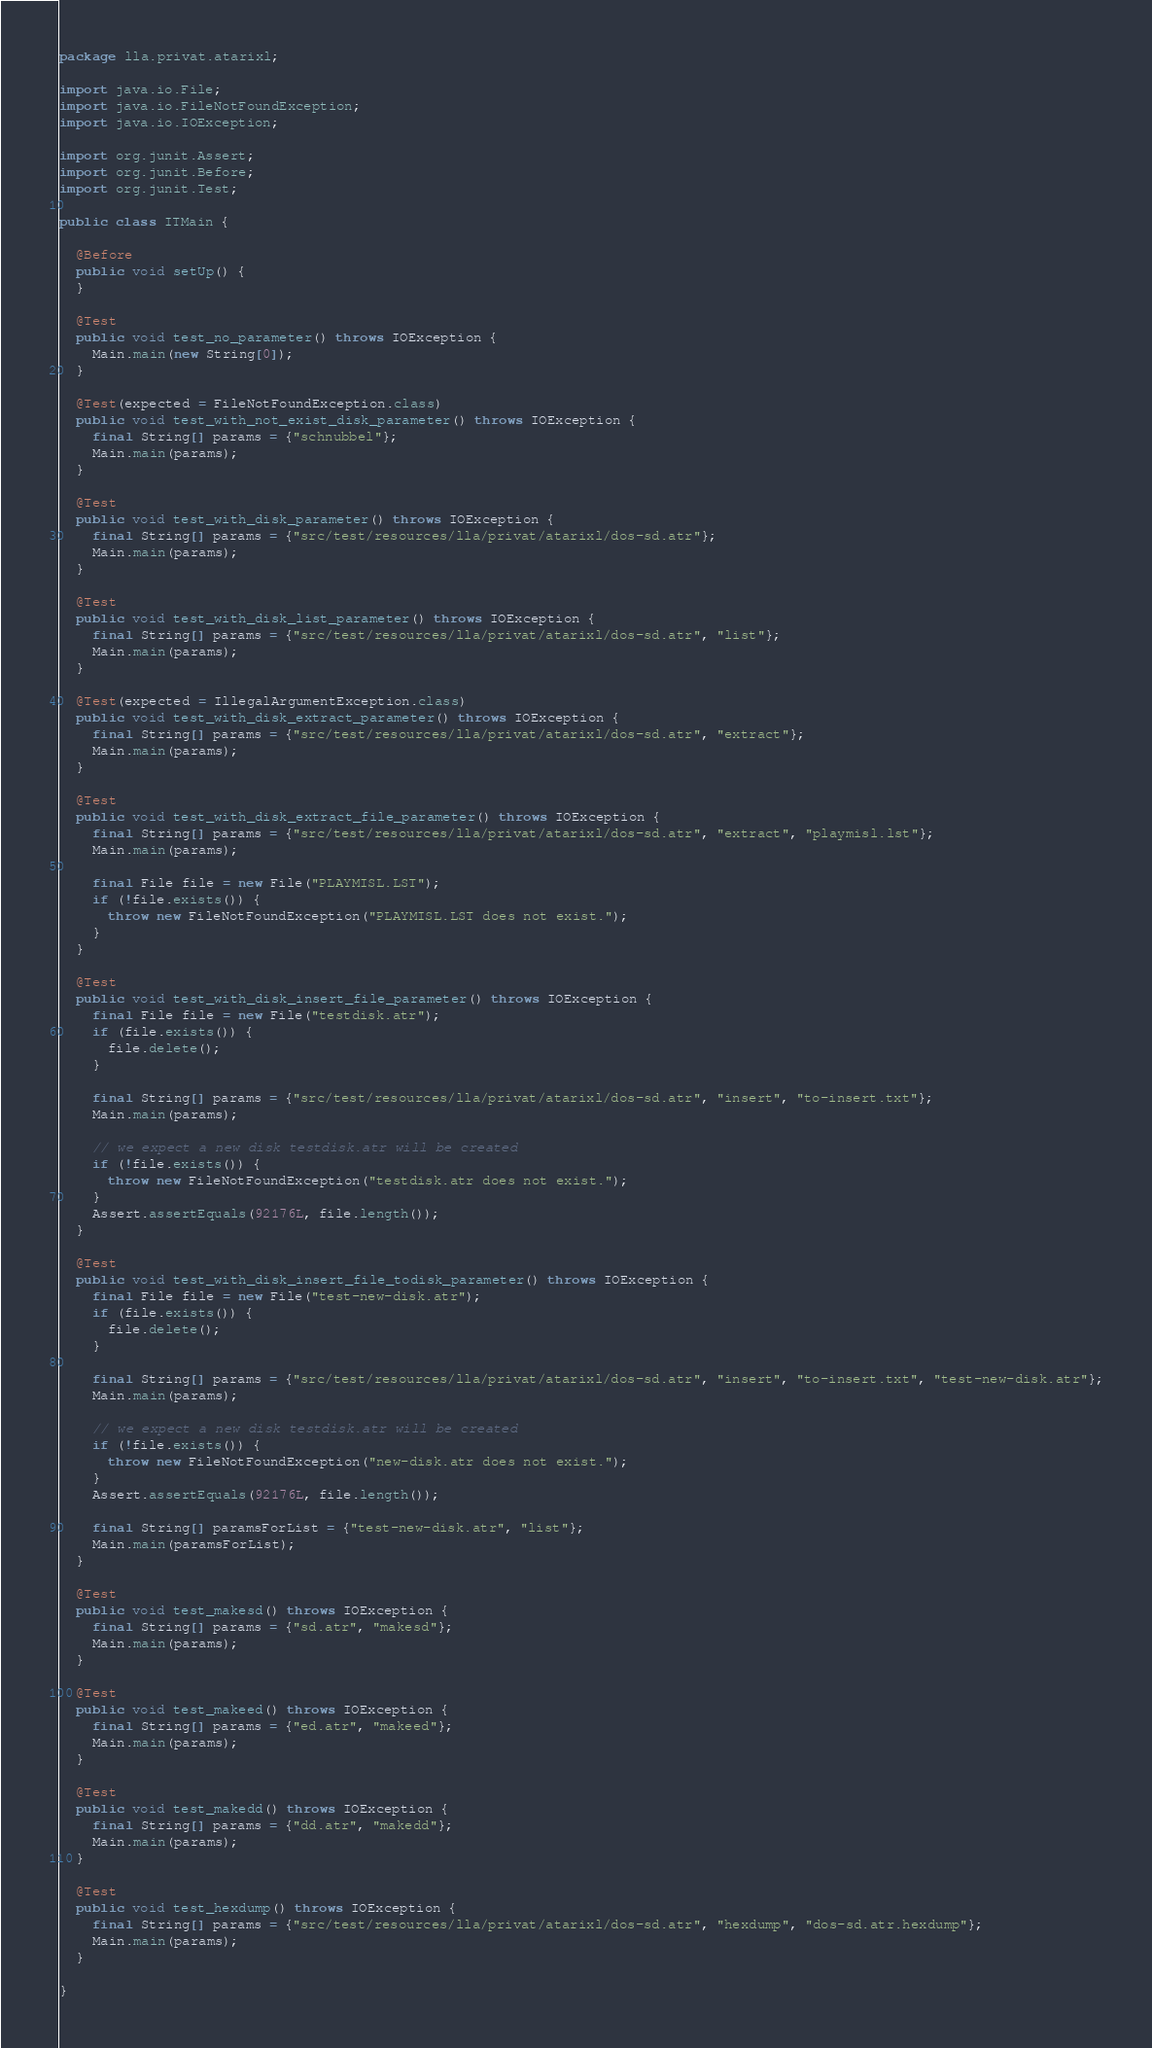Convert code to text. <code><loc_0><loc_0><loc_500><loc_500><_Java_>package lla.privat.atarixl;

import java.io.File;
import java.io.FileNotFoundException;
import java.io.IOException;

import org.junit.Assert;
import org.junit.Before;
import org.junit.Test;

public class ITMain {

  @Before
  public void setUp() {
  }

  @Test
  public void test_no_parameter() throws IOException {
    Main.main(new String[0]);
  }

  @Test(expected = FileNotFoundException.class)
  public void test_with_not_exist_disk_parameter() throws IOException {
    final String[] params = {"schnubbel"};
    Main.main(params);
  }

  @Test
  public void test_with_disk_parameter() throws IOException {
    final String[] params = {"src/test/resources/lla/privat/atarixl/dos-sd.atr"};
    Main.main(params);
  }

  @Test
  public void test_with_disk_list_parameter() throws IOException {
    final String[] params = {"src/test/resources/lla/privat/atarixl/dos-sd.atr", "list"};
    Main.main(params);
  }

  @Test(expected = IllegalArgumentException.class)
  public void test_with_disk_extract_parameter() throws IOException {
    final String[] params = {"src/test/resources/lla/privat/atarixl/dos-sd.atr", "extract"};
    Main.main(params);
  }
  
  @Test
  public void test_with_disk_extract_file_parameter() throws IOException {
    final String[] params = {"src/test/resources/lla/privat/atarixl/dos-sd.atr", "extract", "playmisl.lst"};
    Main.main(params);

    final File file = new File("PLAYMISL.LST");
    if (!file.exists()) {
      throw new FileNotFoundException("PLAYMISL.LST does not exist.");
    }
  }

  @Test
  public void test_with_disk_insert_file_parameter() throws IOException {
    final File file = new File("testdisk.atr");
    if (file.exists()) {
      file.delete();
    }

    final String[] params = {"src/test/resources/lla/privat/atarixl/dos-sd.atr", "insert", "to-insert.txt"};
    Main.main(params);

    // we expect a new disk testdisk.atr will be created
    if (!file.exists()) {
      throw new FileNotFoundException("testdisk.atr does not exist.");
    }
    Assert.assertEquals(92176L, file.length());
  }

  @Test
  public void test_with_disk_insert_file_todisk_parameter() throws IOException {
    final File file = new File("test-new-disk.atr");
    if (file.exists()) {
      file.delete();
    }

    final String[] params = {"src/test/resources/lla/privat/atarixl/dos-sd.atr", "insert", "to-insert.txt", "test-new-disk.atr"};
    Main.main(params);

    // we expect a new disk testdisk.atr will be created
    if (!file.exists()) {
      throw new FileNotFoundException("new-disk.atr does not exist.");
    }
    Assert.assertEquals(92176L, file.length());

    final String[] paramsForList = {"test-new-disk.atr", "list"};
    Main.main(paramsForList);
  }

  @Test
  public void test_makesd() throws IOException {
    final String[] params = {"sd.atr", "makesd"};
    Main.main(params);
  }

  @Test
  public void test_makeed() throws IOException {
    final String[] params = {"ed.atr", "makeed"};
    Main.main(params);
  }

  @Test
  public void test_makedd() throws IOException {
    final String[] params = {"dd.atr", "makedd"};
    Main.main(params);
  }

  @Test
  public void test_hexdump() throws IOException {
    final String[] params = {"src/test/resources/lla/privat/atarixl/dos-sd.atr", "hexdump", "dos-sd.atr.hexdump"};
    Main.main(params);
  }

}
</code> 